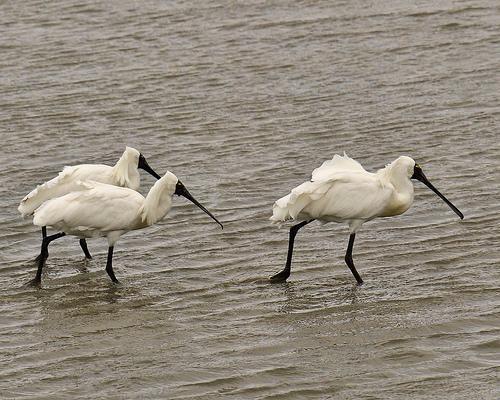How many birds?
Give a very brief answer. 3. How many legs on each bird?
Give a very brief answer. 2. 